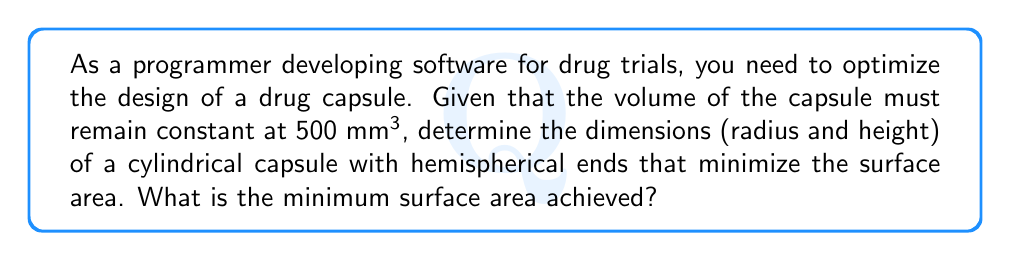Teach me how to tackle this problem. Let's approach this step-by-step:

1) Let $r$ be the radius of the cylinder and $h$ be the height of the cylindrical part (not including the hemispherical ends).

2) The volume of the capsule is the sum of the cylindrical part and the two hemispherical ends:
   $$V = \pi r^2 h + \frac{4}{3}\pi r^3 = 500$$

3) The surface area is the sum of the curved surface of the cylinder and the surface area of the two hemispheres:
   $$S = 2\pi rh + 4\pi r^2$$

4) From the volume equation, we can express $h$ in terms of $r$:
   $$h = \frac{500 - \frac{4}{3}\pi r^3}{\pi r^2}$$

5) Substituting this into the surface area equation:
   $$S = 2\pi r(\frac{500 - \frac{4}{3}\pi r^3}{\pi r^2}) + 4\pi r^2$$
   $$S = \frac{1000}{r} - \frac{8}{3}\pi r + 4\pi r^2$$

6) To find the minimum, we differentiate $S$ with respect to $r$ and set it to zero:
   $$\frac{dS}{dr} = -\frac{1000}{r^2} - \frac{8}{3}\pi + 8\pi r = 0$$

7) Solving this equation:
   $$8\pi r^3 + \frac{8}{3}\pi r^2 - 1000 = 0$$

8) This cubic equation can be solved numerically. The solution is approximately:
   $$r \approx 5.42 \text{ mm}$$

9) We can then find $h$:
   $$h \approx 6.84 \text{ mm}$$

10) The minimum surface area is thus:
    $$S_{min} = 2\pi r h + 4\pi r^2 \approx 452.4 \text{ mm}^2$$

[asy]
import geometry;

real r = 5.42;
real h = 6.84;

path p = (0,0)--(0,h)--(r,h)--(r,0)--cycle;
draw(p);
draw(arc((0,h),r,0,180));
draw(arc((0,0),r,180,360));
draw((0,-r)--(0,h+r),dashed);
draw((-r-1,0)--(r+1,0),dashed);

label("r", (r/2,-r/2), E);
label("h", (-r/2,h/2), W);
label("r", (0,h+r/2), E);

[/asy]
Answer: 452.4 mm² 